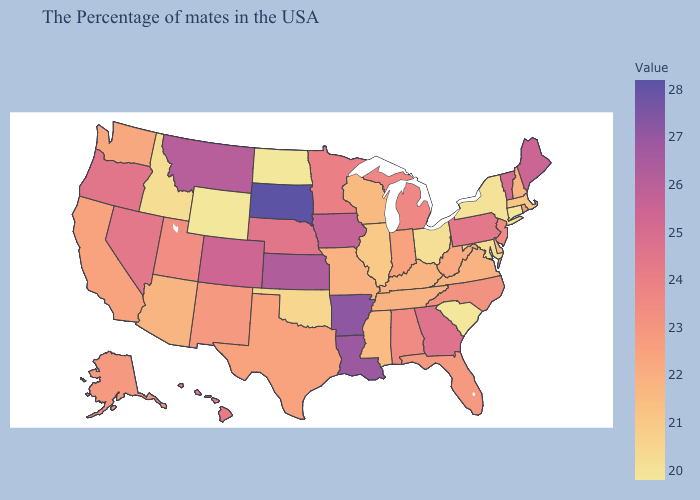Among the states that border Georgia , does Alabama have the lowest value?
Write a very short answer. No. Among the states that border Illinois , does Iowa have the lowest value?
Concise answer only. No. Among the states that border Maryland , which have the lowest value?
Give a very brief answer. Delaware. Does New Jersey have the lowest value in the USA?
Write a very short answer. No. Does South Dakota have the highest value in the MidWest?
Answer briefly. Yes. Does Pennsylvania have the highest value in the USA?
Keep it brief. No. Which states hav the highest value in the West?
Write a very short answer. Montana. Does South Dakota have the highest value in the USA?
Be succinct. Yes. 